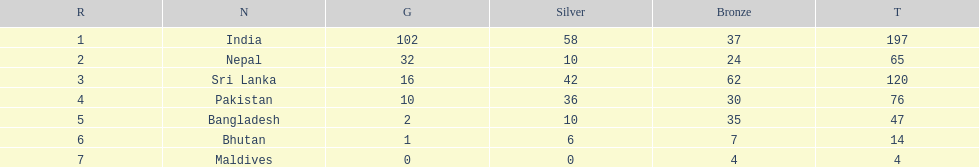Which nation has earned the least amount of gold medals? Maldives. 